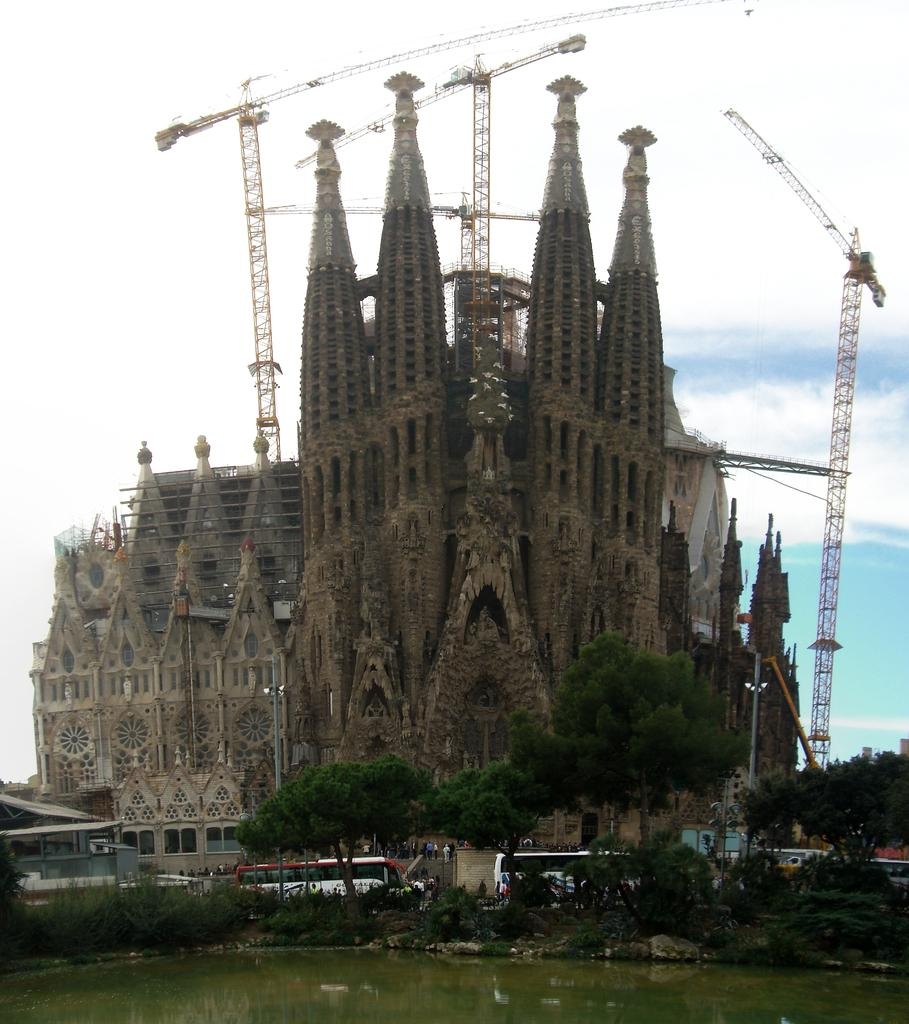What is the primary element visible in the image? There is water in the image. What type of vegetation can be seen in the image? There are trees and plants from left to right in the image. What type of structure is present in the image? There is a building in the image. What type of machinery is present in the image? There are cranes in the image. How would you describe the sky in the image? The sky is blue and cloudy in the image. What type of mitten is being used to sort the head in the image? There is no mitten or head present in the image. 